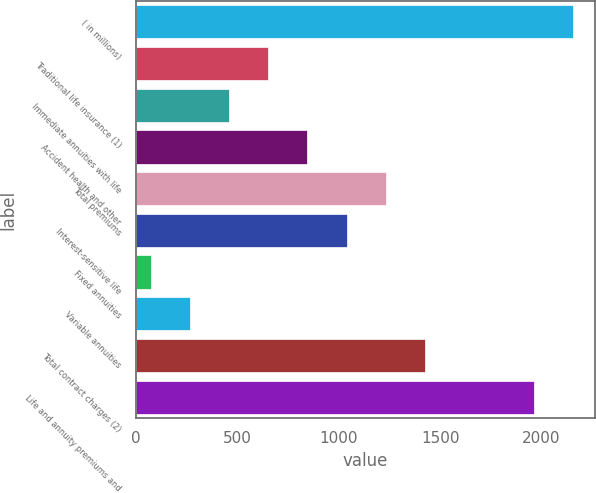<chart> <loc_0><loc_0><loc_500><loc_500><bar_chart><fcel>( in millions)<fcel>Traditional life insurance (1)<fcel>Immediate annuities with life<fcel>Accident health and other<fcel>Total premiums<fcel>Interest-sensitive life<fcel>Fixed annuities<fcel>Variable annuities<fcel>Total contract charges (2)<fcel>Life and annuity premiums and<nl><fcel>2157.3<fcel>652.9<fcel>459.6<fcel>846.2<fcel>1232.8<fcel>1039.5<fcel>73<fcel>266.3<fcel>1426.1<fcel>1964<nl></chart> 